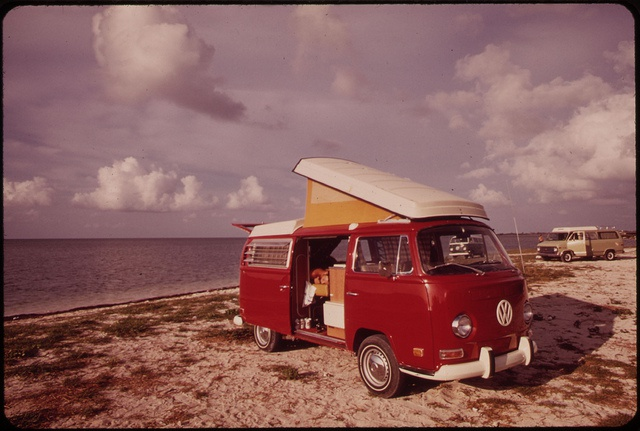Describe the objects in this image and their specific colors. I can see truck in black, maroon, and tan tones, truck in black, maroon, brown, and tan tones, and people in black, maroon, and brown tones in this image. 